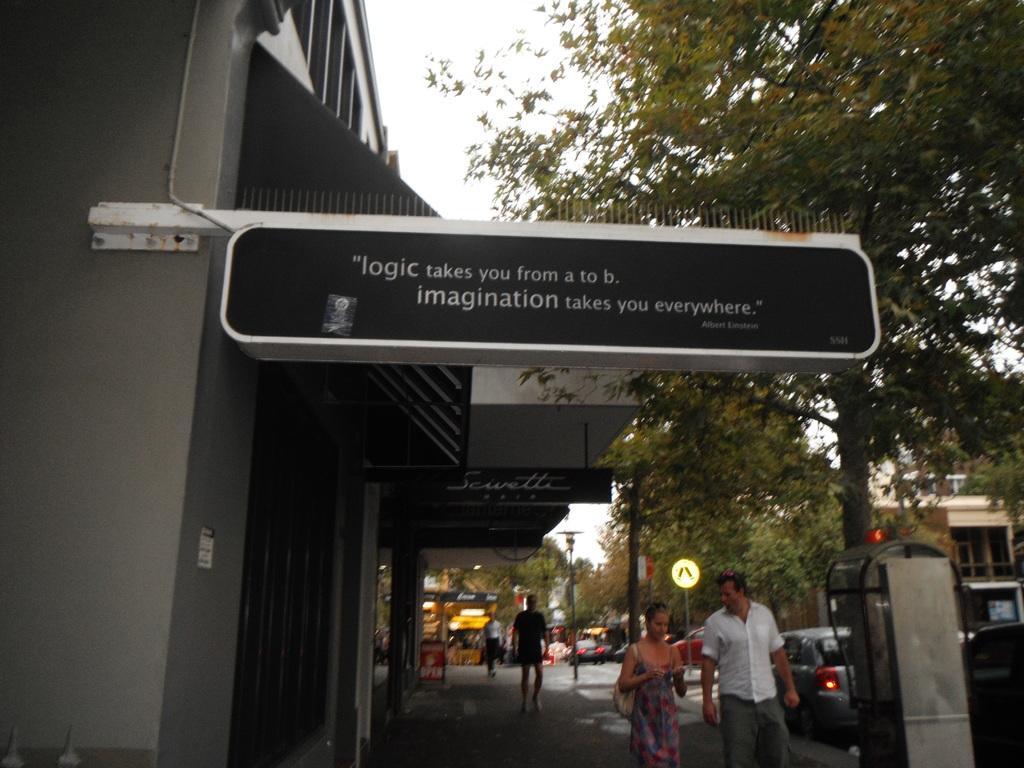Could you give a brief overview of what you see in this image? In this image I can see the board attached to the wall and the board is in black color. In the background I can see few people walking and I can see few poles, stalls, trees in green color and the sky is in white color. 